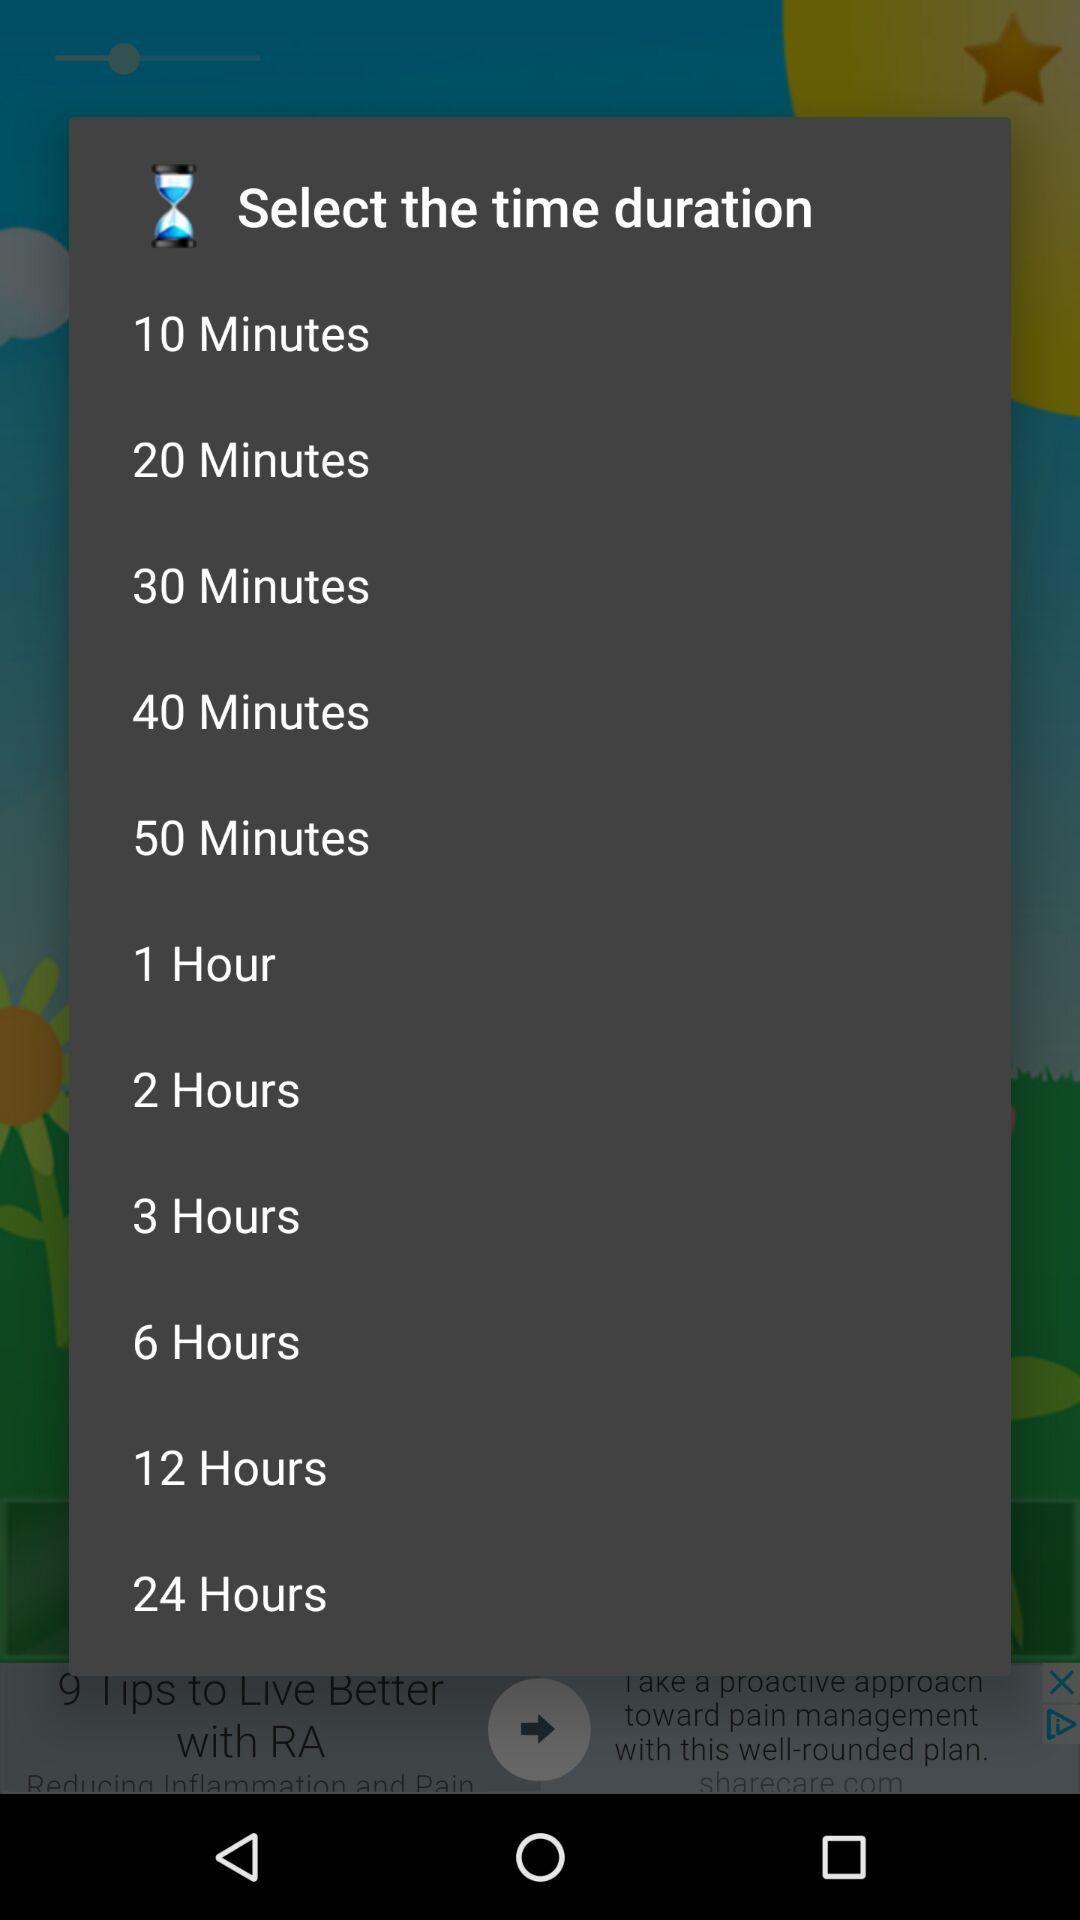What is the maximum time duration?
When the provided information is insufficient, respond with <no answer>. <no answer> 